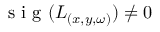Convert formula to latex. <formula><loc_0><loc_0><loc_500><loc_500>s i g ( { L } _ { ( x , y , \omega ) } ) \ne 0</formula> 